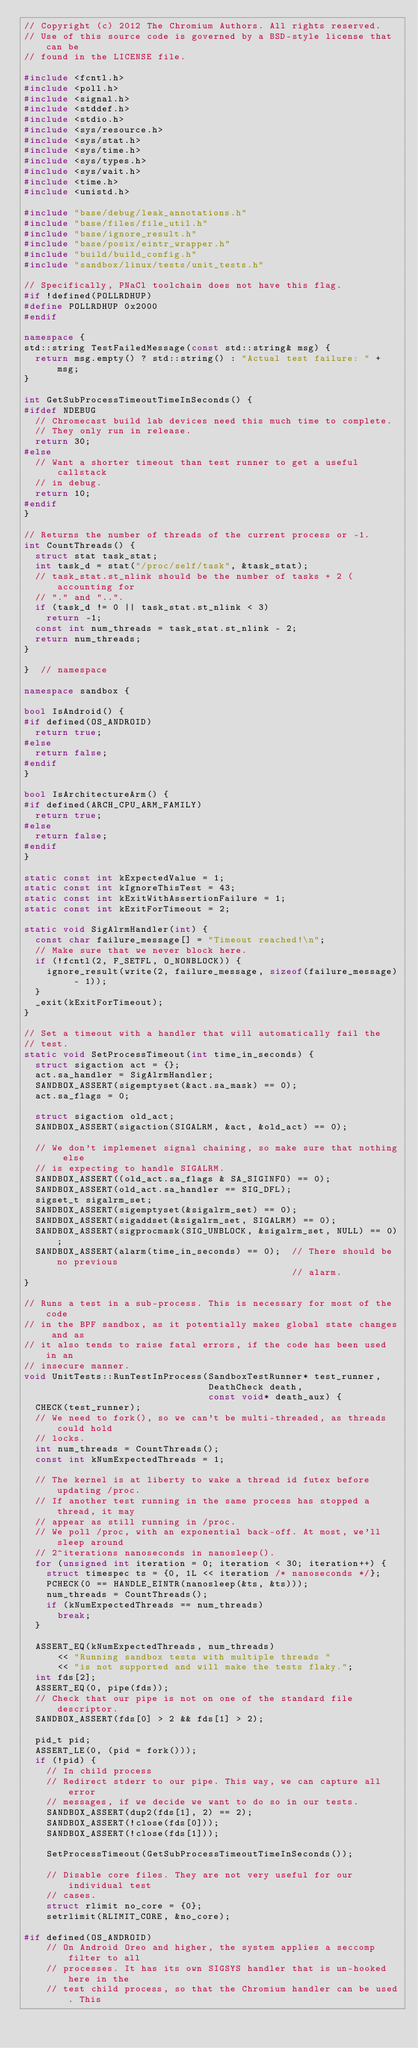Convert code to text. <code><loc_0><loc_0><loc_500><loc_500><_C++_>// Copyright (c) 2012 The Chromium Authors. All rights reserved.
// Use of this source code is governed by a BSD-style license that can be
// found in the LICENSE file.

#include <fcntl.h>
#include <poll.h>
#include <signal.h>
#include <stddef.h>
#include <stdio.h>
#include <sys/resource.h>
#include <sys/stat.h>
#include <sys/time.h>
#include <sys/types.h>
#include <sys/wait.h>
#include <time.h>
#include <unistd.h>

#include "base/debug/leak_annotations.h"
#include "base/files/file_util.h"
#include "base/ignore_result.h"
#include "base/posix/eintr_wrapper.h"
#include "build/build_config.h"
#include "sandbox/linux/tests/unit_tests.h"

// Specifically, PNaCl toolchain does not have this flag.
#if !defined(POLLRDHUP)
#define POLLRDHUP 0x2000
#endif

namespace {
std::string TestFailedMessage(const std::string& msg) {
  return msg.empty() ? std::string() : "Actual test failure: " + msg;
}

int GetSubProcessTimeoutTimeInSeconds() {
#ifdef NDEBUG
  // Chromecast build lab devices need this much time to complete.
  // They only run in release.
  return 30;
#else
  // Want a shorter timeout than test runner to get a useful callstack
  // in debug.
  return 10;
#endif
}

// Returns the number of threads of the current process or -1.
int CountThreads() {
  struct stat task_stat;
  int task_d = stat("/proc/self/task", &task_stat);
  // task_stat.st_nlink should be the number of tasks + 2 (accounting for
  // "." and "..".
  if (task_d != 0 || task_stat.st_nlink < 3)
    return -1;
  const int num_threads = task_stat.st_nlink - 2;
  return num_threads;
}

}  // namespace

namespace sandbox {

bool IsAndroid() {
#if defined(OS_ANDROID)
  return true;
#else
  return false;
#endif
}

bool IsArchitectureArm() {
#if defined(ARCH_CPU_ARM_FAMILY)
  return true;
#else
  return false;
#endif
}

static const int kExpectedValue = 1;
static const int kIgnoreThisTest = 43;
static const int kExitWithAssertionFailure = 1;
static const int kExitForTimeout = 2;

static void SigAlrmHandler(int) {
  const char failure_message[] = "Timeout reached!\n";
  // Make sure that we never block here.
  if (!fcntl(2, F_SETFL, O_NONBLOCK)) {
    ignore_result(write(2, failure_message, sizeof(failure_message) - 1));
  }
  _exit(kExitForTimeout);
}

// Set a timeout with a handler that will automatically fail the
// test.
static void SetProcessTimeout(int time_in_seconds) {
  struct sigaction act = {};
  act.sa_handler = SigAlrmHandler;
  SANDBOX_ASSERT(sigemptyset(&act.sa_mask) == 0);
  act.sa_flags = 0;

  struct sigaction old_act;
  SANDBOX_ASSERT(sigaction(SIGALRM, &act, &old_act) == 0);

  // We don't implemenet signal chaining, so make sure that nothing else
  // is expecting to handle SIGALRM.
  SANDBOX_ASSERT((old_act.sa_flags & SA_SIGINFO) == 0);
  SANDBOX_ASSERT(old_act.sa_handler == SIG_DFL);
  sigset_t sigalrm_set;
  SANDBOX_ASSERT(sigemptyset(&sigalrm_set) == 0);
  SANDBOX_ASSERT(sigaddset(&sigalrm_set, SIGALRM) == 0);
  SANDBOX_ASSERT(sigprocmask(SIG_UNBLOCK, &sigalrm_set, NULL) == 0);
  SANDBOX_ASSERT(alarm(time_in_seconds) == 0);  // There should be no previous
                                                // alarm.
}

// Runs a test in a sub-process. This is necessary for most of the code
// in the BPF sandbox, as it potentially makes global state changes and as
// it also tends to raise fatal errors, if the code has been used in an
// insecure manner.
void UnitTests::RunTestInProcess(SandboxTestRunner* test_runner,
                                 DeathCheck death,
                                 const void* death_aux) {
  CHECK(test_runner);
  // We need to fork(), so we can't be multi-threaded, as threads could hold
  // locks.
  int num_threads = CountThreads();
  const int kNumExpectedThreads = 1;

  // The kernel is at liberty to wake a thread id futex before updating /proc.
  // If another test running in the same process has stopped a thread, it may
  // appear as still running in /proc.
  // We poll /proc, with an exponential back-off. At most, we'll sleep around
  // 2^iterations nanoseconds in nanosleep().
  for (unsigned int iteration = 0; iteration < 30; iteration++) {
    struct timespec ts = {0, 1L << iteration /* nanoseconds */};
    PCHECK(0 == HANDLE_EINTR(nanosleep(&ts, &ts)));
    num_threads = CountThreads();
    if (kNumExpectedThreads == num_threads)
      break;
  }

  ASSERT_EQ(kNumExpectedThreads, num_threads)
      << "Running sandbox tests with multiple threads "
      << "is not supported and will make the tests flaky.";
  int fds[2];
  ASSERT_EQ(0, pipe(fds));
  // Check that our pipe is not on one of the standard file descriptor.
  SANDBOX_ASSERT(fds[0] > 2 && fds[1] > 2);

  pid_t pid;
  ASSERT_LE(0, (pid = fork()));
  if (!pid) {
    // In child process
    // Redirect stderr to our pipe. This way, we can capture all error
    // messages, if we decide we want to do so in our tests.
    SANDBOX_ASSERT(dup2(fds[1], 2) == 2);
    SANDBOX_ASSERT(!close(fds[0]));
    SANDBOX_ASSERT(!close(fds[1]));

    SetProcessTimeout(GetSubProcessTimeoutTimeInSeconds());

    // Disable core files. They are not very useful for our individual test
    // cases.
    struct rlimit no_core = {0};
    setrlimit(RLIMIT_CORE, &no_core);

#if defined(OS_ANDROID)
    // On Android Oreo and higher, the system applies a seccomp filter to all
    // processes. It has its own SIGSYS handler that is un-hooked here in the
    // test child process, so that the Chromium handler can be used. This</code> 